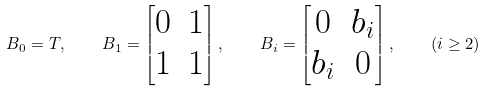Convert formula to latex. <formula><loc_0><loc_0><loc_500><loc_500>B _ { 0 } = T , \quad B _ { 1 } = \begin{bmatrix} 0 & 1 \\ 1 & 1 \end{bmatrix} , \quad B _ { i } = \begin{bmatrix} 0 & b _ { i } \\ b _ { i } & 0 \end{bmatrix} , \quad ( i \geq 2 )</formula> 